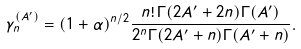<formula> <loc_0><loc_0><loc_500><loc_500>\gamma _ { n } ^ { ( A ^ { \prime } ) } = ( 1 + \alpha ) ^ { n / 2 } \frac { n ! \, \Gamma ( 2 A ^ { \prime } + 2 n ) \Gamma ( A ^ { \prime } ) } { 2 ^ { n } \Gamma ( 2 A ^ { \prime } + n ) \Gamma ( A ^ { \prime } + n ) } .</formula> 